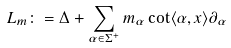Convert formula to latex. <formula><loc_0><loc_0><loc_500><loc_500>L _ { m } \colon = \Delta + \sum _ { \alpha \in \Sigma ^ { + } } m _ { \alpha } \cot \langle \alpha , x \rangle \partial _ { \alpha }</formula> 